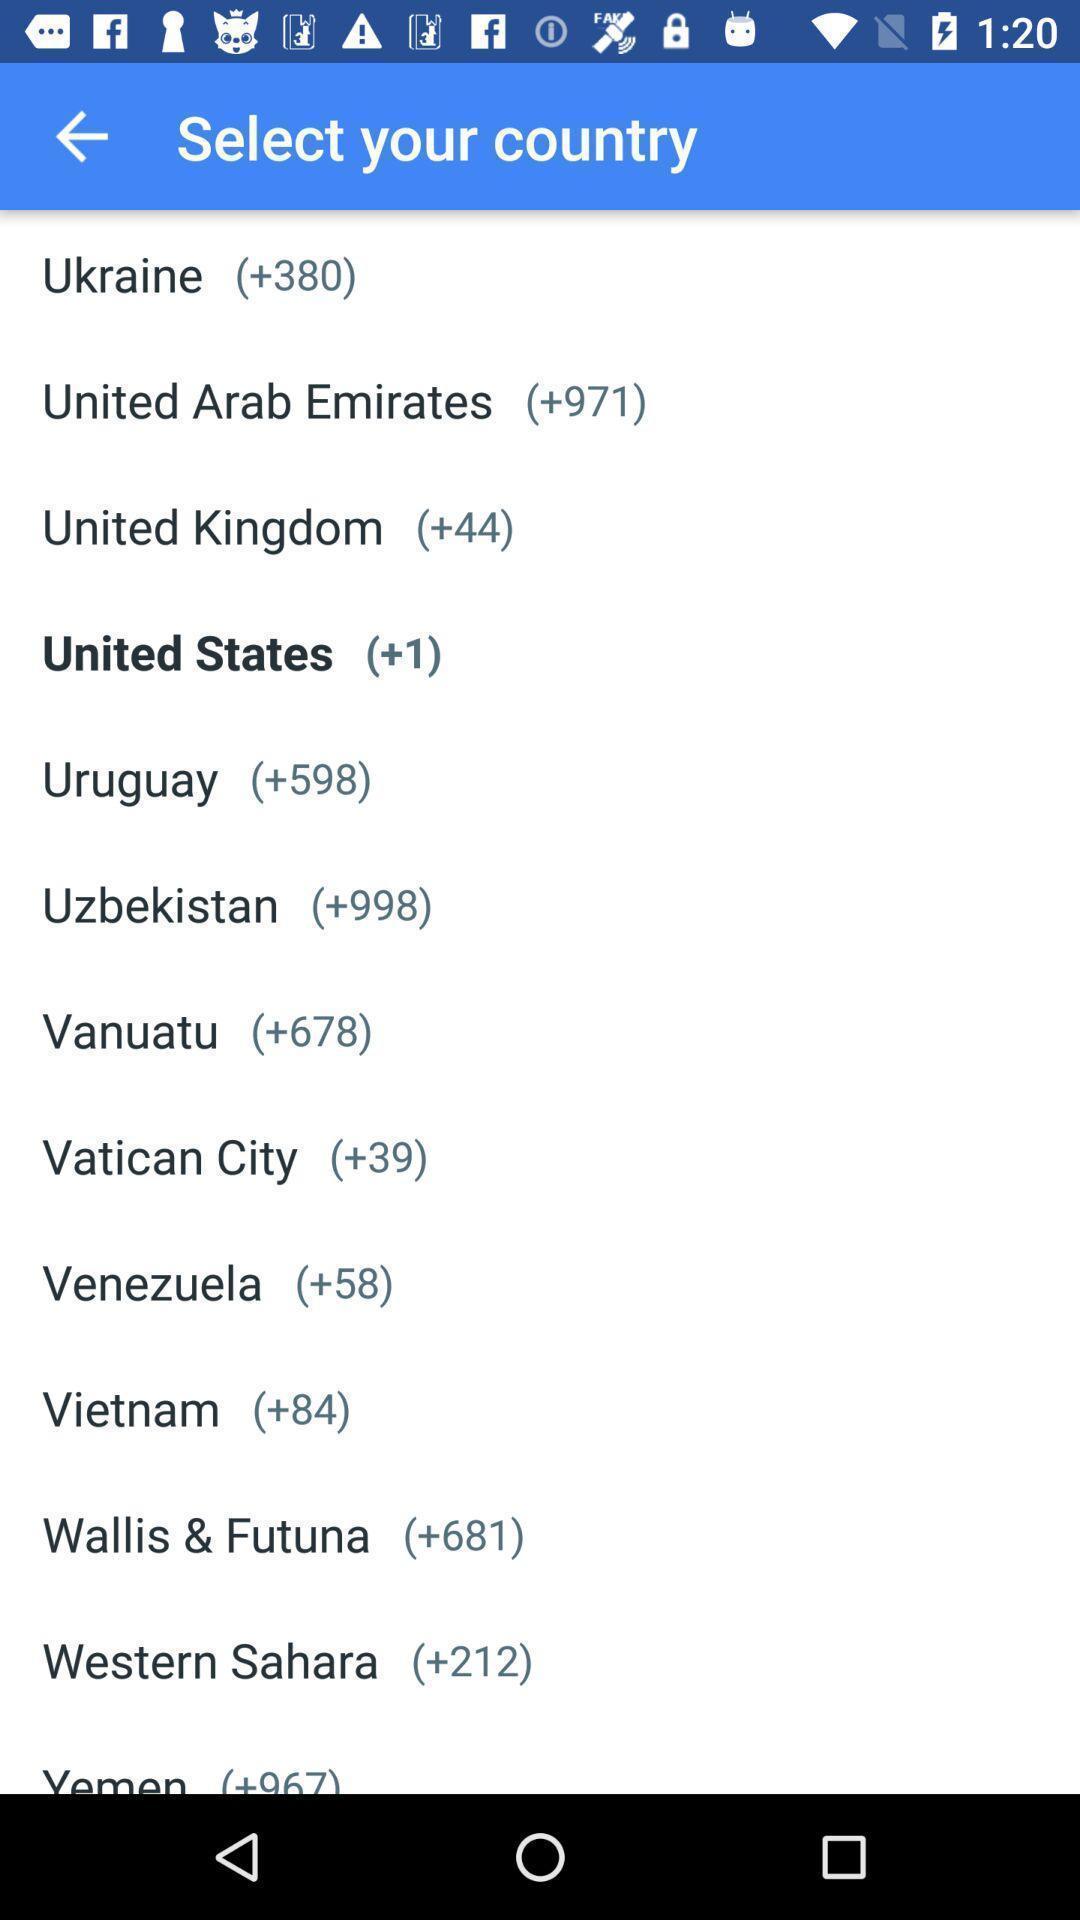Provide a description of this screenshot. Screen showing various options to select your country. 